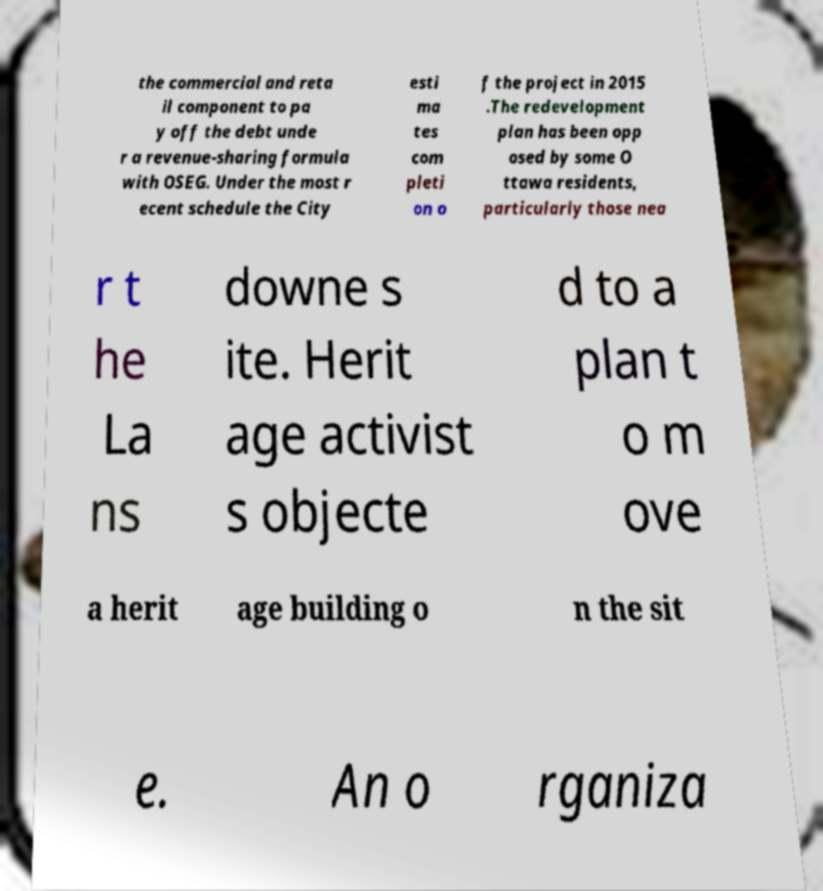Can you accurately transcribe the text from the provided image for me? the commercial and reta il component to pa y off the debt unde r a revenue-sharing formula with OSEG. Under the most r ecent schedule the City esti ma tes com pleti on o f the project in 2015 .The redevelopment plan has been opp osed by some O ttawa residents, particularly those nea r t he La ns downe s ite. Herit age activist s objecte d to a plan t o m ove a herit age building o n the sit e. An o rganiza 